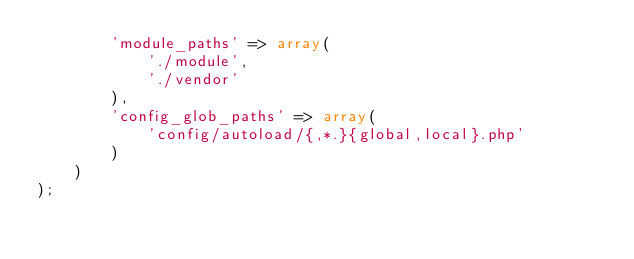<code> <loc_0><loc_0><loc_500><loc_500><_PHP_>        'module_paths' => array(
            './module',
            './vendor'
        ),
        'config_glob_paths' => array(
            'config/autoload/{,*.}{global,local}.php'
        )
    )
);
</code> 